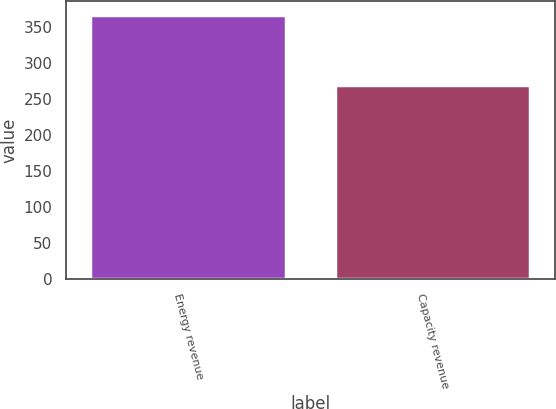Convert chart to OTSL. <chart><loc_0><loc_0><loc_500><loc_500><bar_chart><fcel>Energy revenue<fcel>Capacity revenue<nl><fcel>367<fcel>269<nl></chart> 